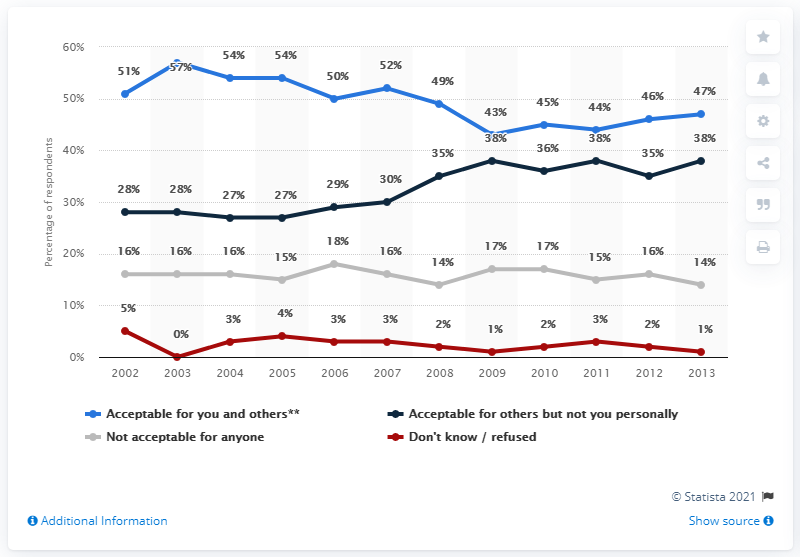Identify some key points in this picture. A zero value occurred in one year, and the year in question is 2003. The average of the last four years is shown in the blue line chart, with a value of 45.5. 